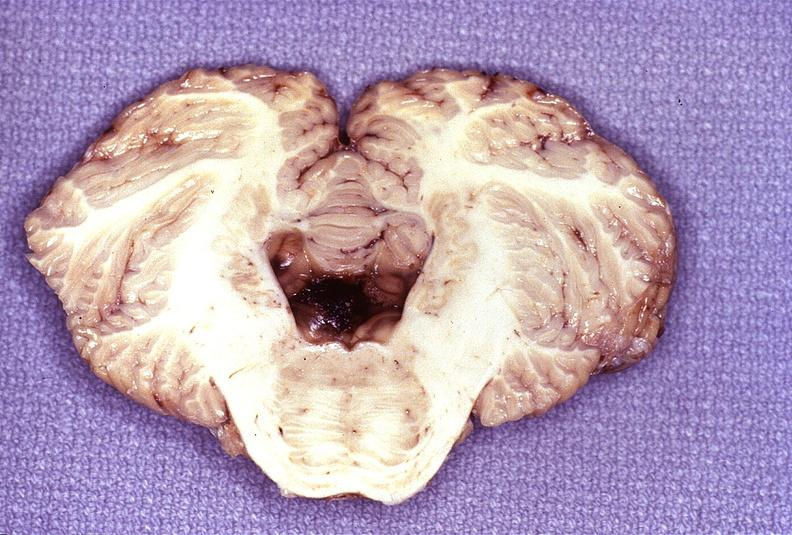does this image show wernicke 's encephalopathy?
Answer the question using a single word or phrase. Yes 